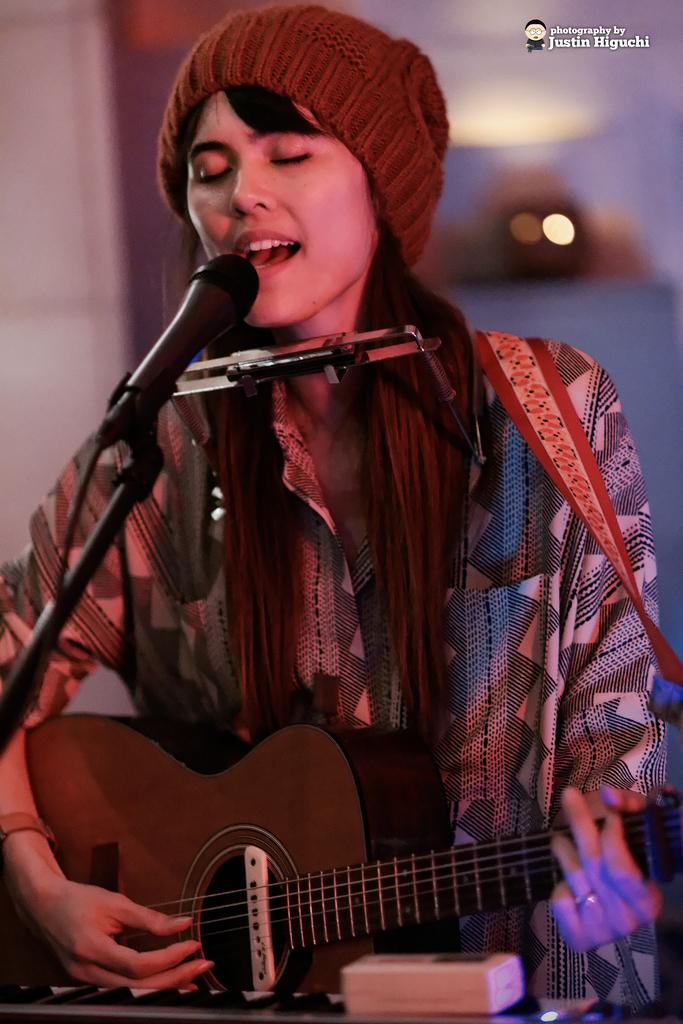What is the main subject of the image? There is a person in the image. What is the person wearing? The person is wearing a white dress and a brown hat. What is the person doing in the image? The person is playing a guitar. What object is in front of the person? There is a microphone in front of the person. How many chairs are visible in the image? There are no chairs visible in the image. What type of pest can be seen crawling on the person's guitar in the image? There are no pests visible in the image; the person is playing a guitar without any visible pests. 